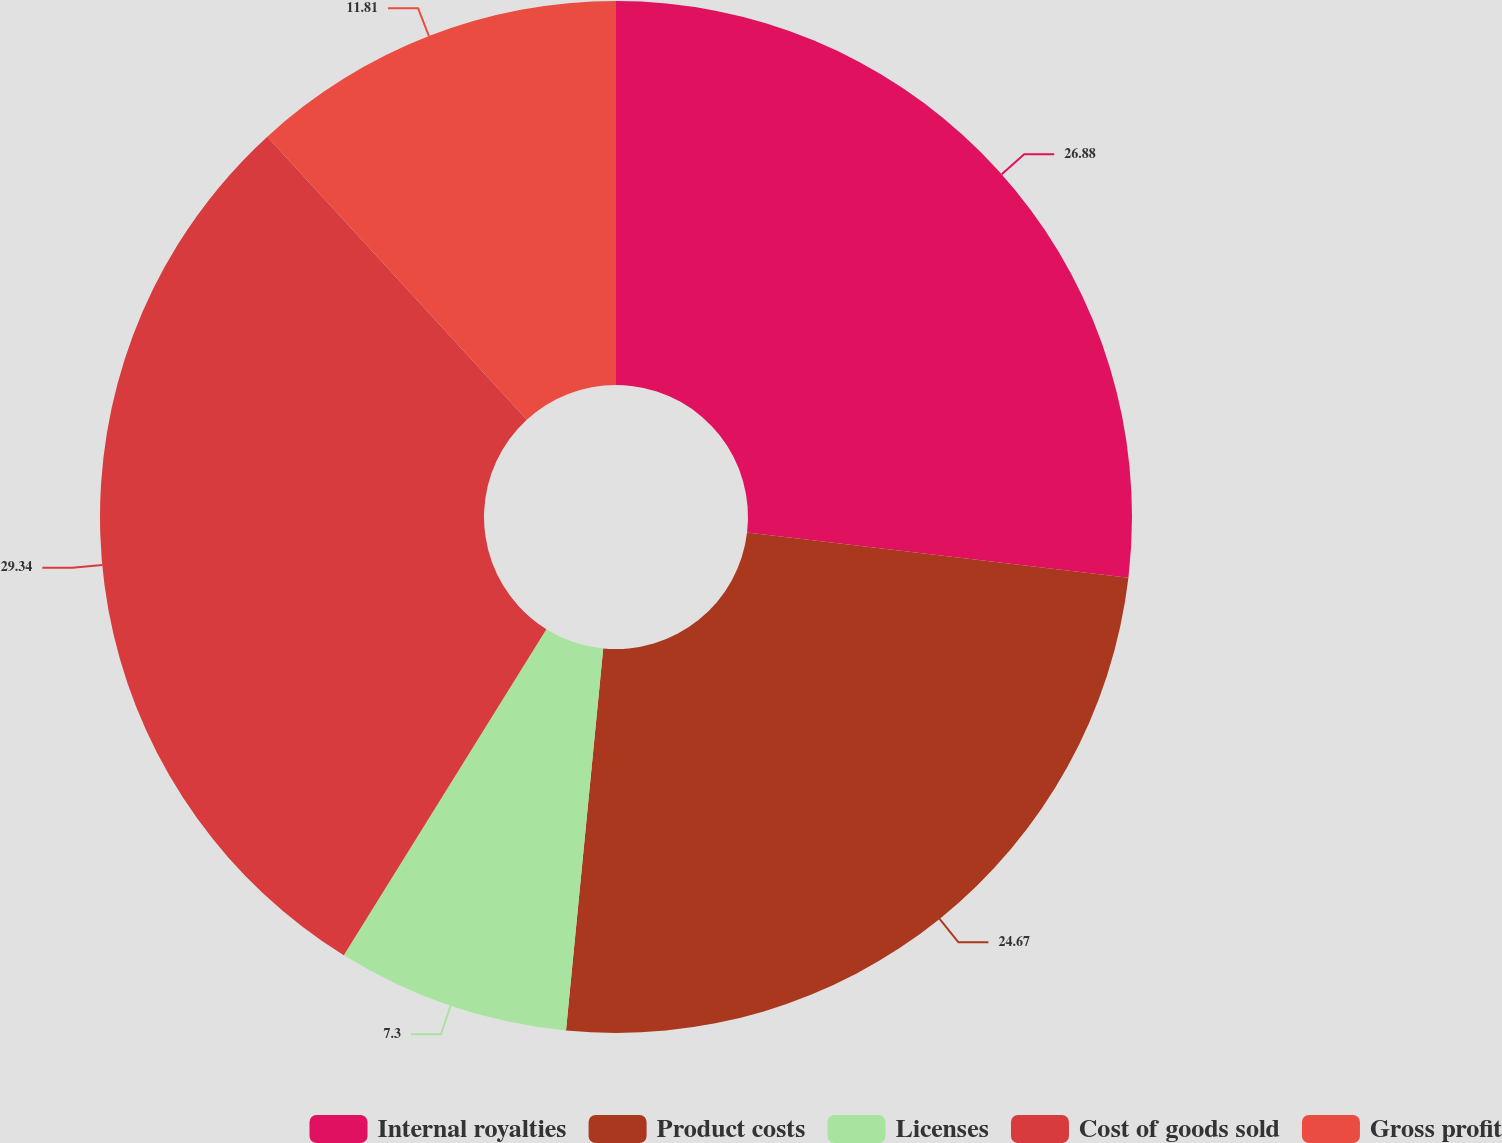Convert chart. <chart><loc_0><loc_0><loc_500><loc_500><pie_chart><fcel>Internal royalties<fcel>Product costs<fcel>Licenses<fcel>Cost of goods sold<fcel>Gross profit<nl><fcel>26.88%<fcel>24.67%<fcel>7.3%<fcel>29.35%<fcel>11.81%<nl></chart> 